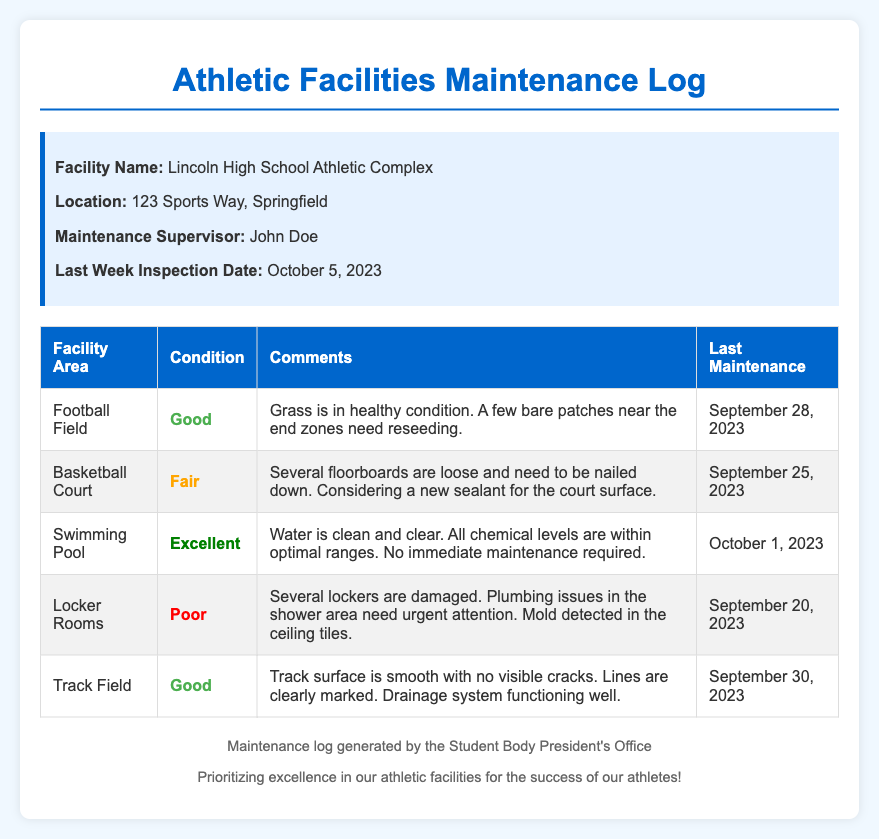What is the facility name? The facility name is stated at the top of the document, listed under the facility info section.
Answer: Lincoln High School Athletic Complex Who is the maintenance supervisor? The document specifies the name of the maintenance supervisor in the facility info section.
Answer: John Doe What is the condition of the swimming pool? The condition of the swimming pool is listed in the table under the swimming pool entry.
Answer: Excellent What urgent issue is noted in the locker rooms? The specific urgent issues in the locker rooms are highlighted in the comments column of the locker rooms entry in the table.
Answer: Plumbing issues When was the last maintenance for the basketball court? This date is provided in the last maintenance column of the basketball court entry in the table.
Answer: September 25, 2023 Which facility area has a condition classified as 'poor'? The table lists the condition of each facility area, and 'poor' can be found in the locker rooms entry.
Answer: Locker Rooms What is the comment regarding the football field's condition? Comments about the football field’s condition are in the comments column of the football field entry in the table.
Answer: Grass is in healthy condition. A few bare patches near the end zones need reseeding How many areas listed have a 'good' condition? By counting the entries in the condition column of the table, we find the number of areas with 'good'.
Answer: 3 